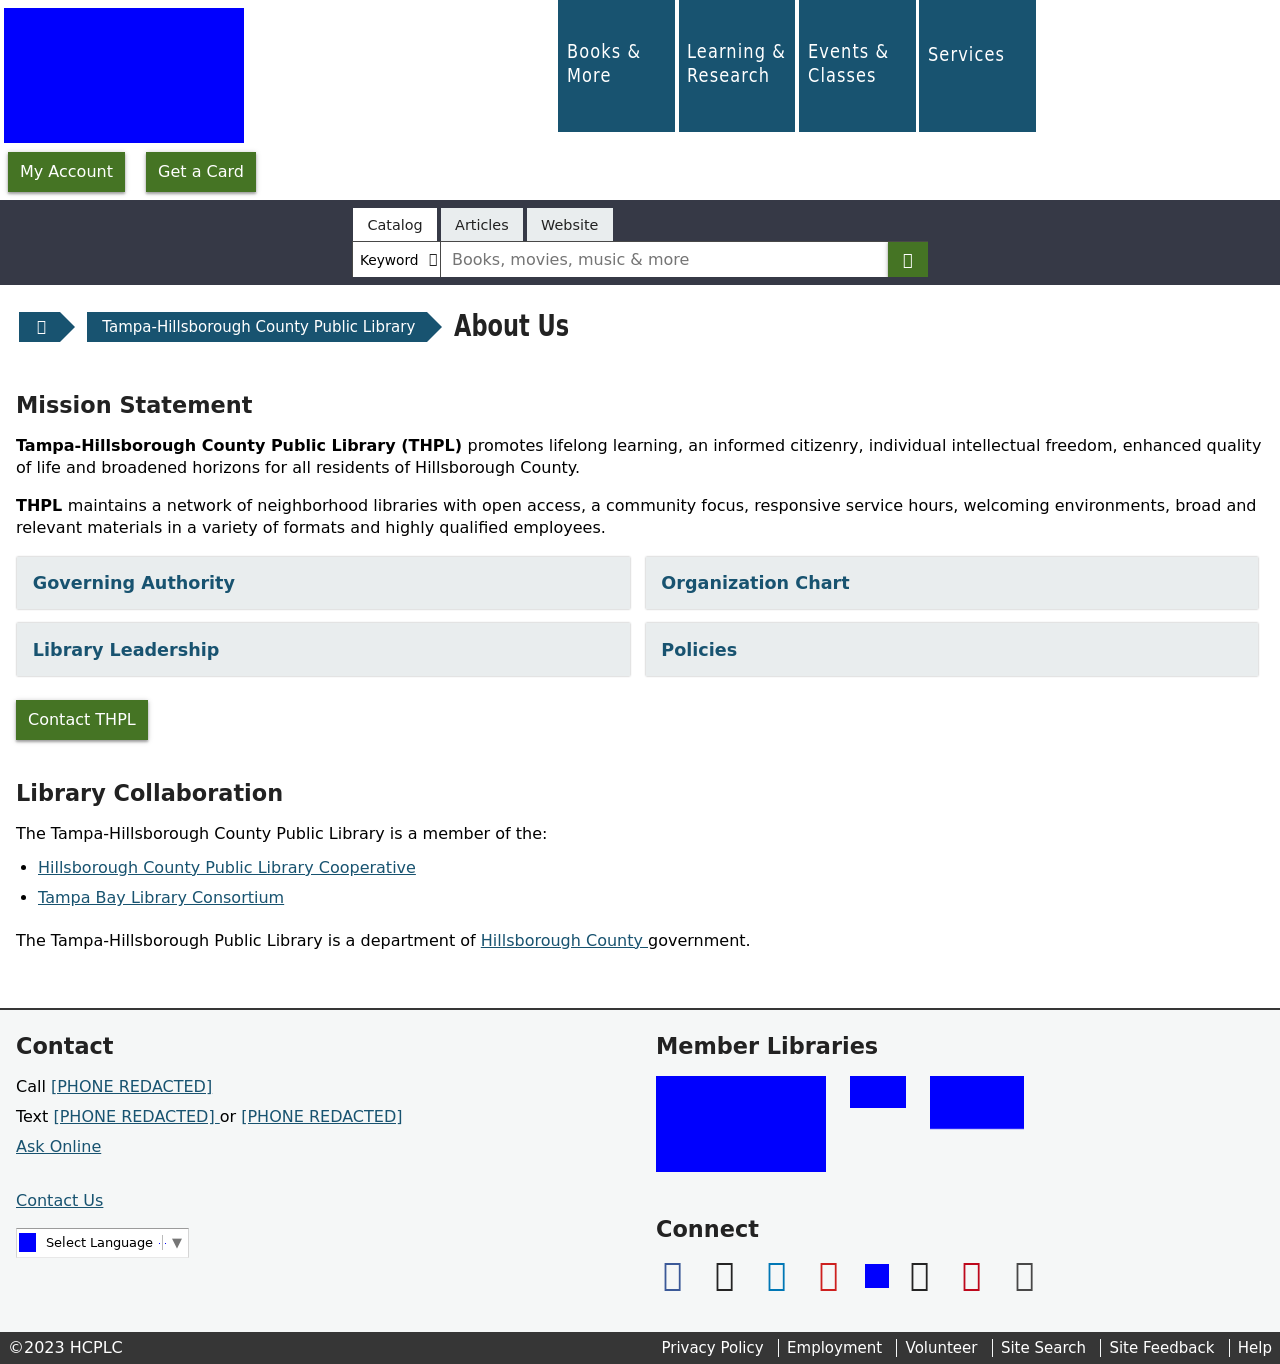What's the procedure for constructing this website from scratch with HTML? To construct a website similar to the one displayed in the image from scratch, you would need to start by defining the fundamental structure with HTML. This includes setting up the basic document structure with <html>, <head>, and <body> tags. Within the head, you would include meta tags for responsive design and link to CSS for styles. In the body, you would structure the navbar, main content regions, footer, and any additional sections. The main content would typically involve using <div> elements to segment the site into logical blocks, such as the menu, mission statement, and contact information areas observed in the screenshot. Each section could be further styled using CSS to achieve the visual aesthetics of layouts, typography, and color schemes as seen. 